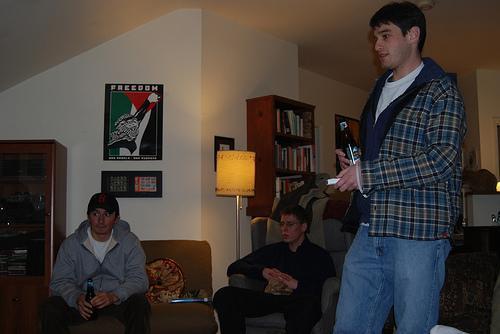How many people are there?
Give a very brief answer. 3. 